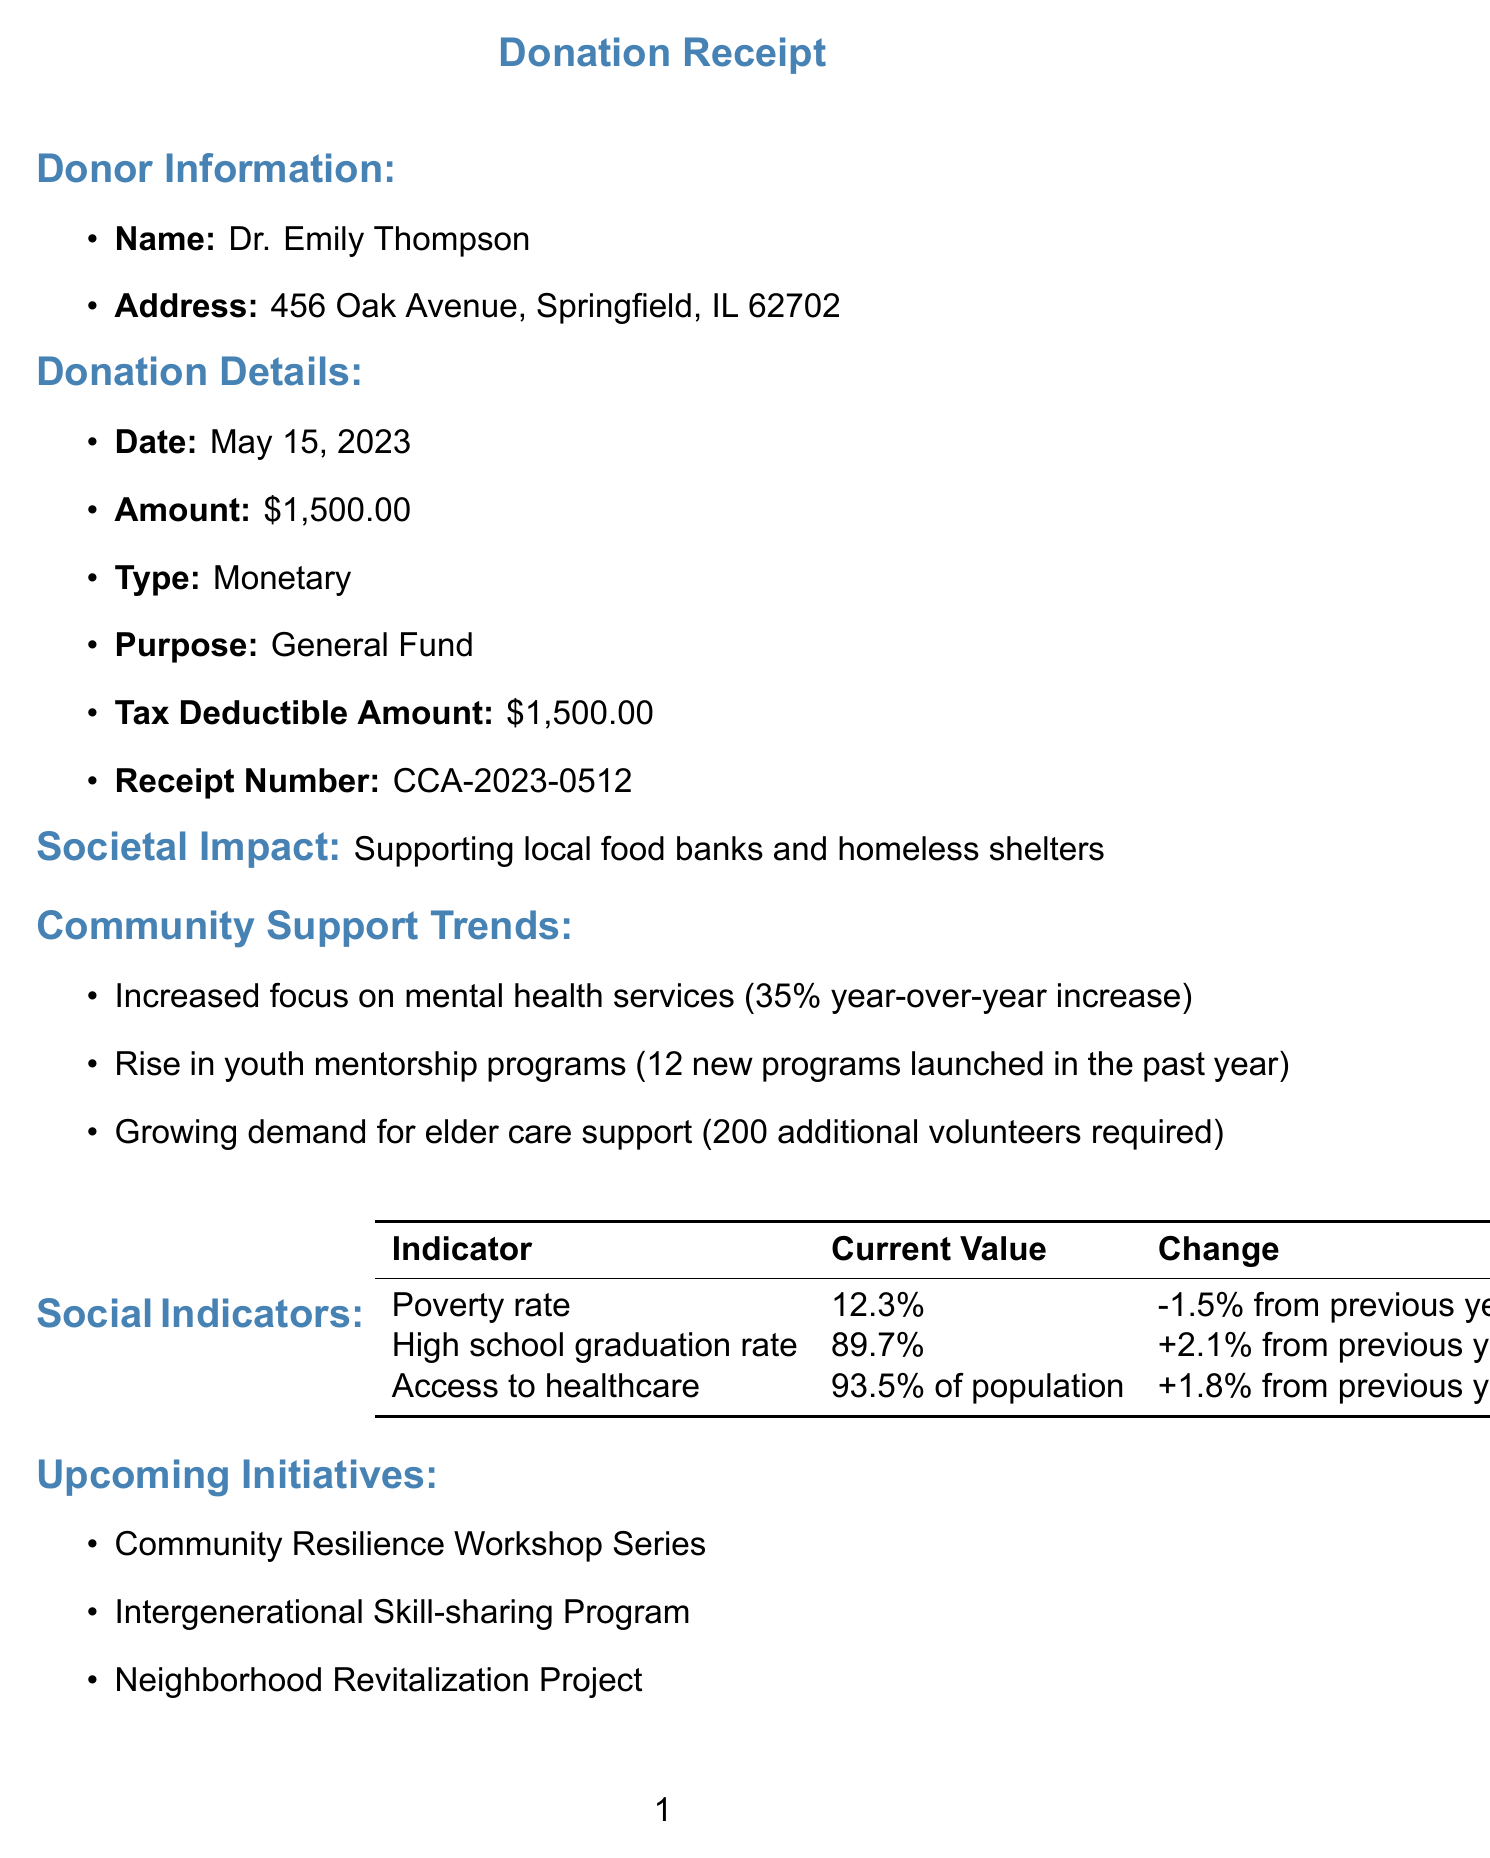What is the name of the organization? The name of the organization is provided in the heading of the document.
Answer: Community Care Alliance Who is the donor? The donor's name is stated in the donor information section of the document.
Answer: Dr. Emily Thompson What was the donation amount? The donation amount is listed under donation details in the document.
Answer: $1,500.00 What is one purpose of the donation? The purpose of the donation is mentioned in the donation details section.
Answer: General Fund What is the percentage increase in mental health services? The percentage increase is outlined in the community support trends section.
Answer: 35% year-over-year How many youth mentorship programs were launched in the past year? The number of new youth mentorship programs is listed in the community support trends section.
Answer: 12 launched What is the current poverty rate? The current poverty rate is specified in the social indicators table of the document.
Answer: 12.3% What is one upcoming initiative mentioned? The upcoming initiatives are listed towards the end of the document.
Answer: Community Resilience Workshop Series Who is the chairperson of the board? The chairperson is identified in the board of directors section.
Answer: Dr. Michael Chen 